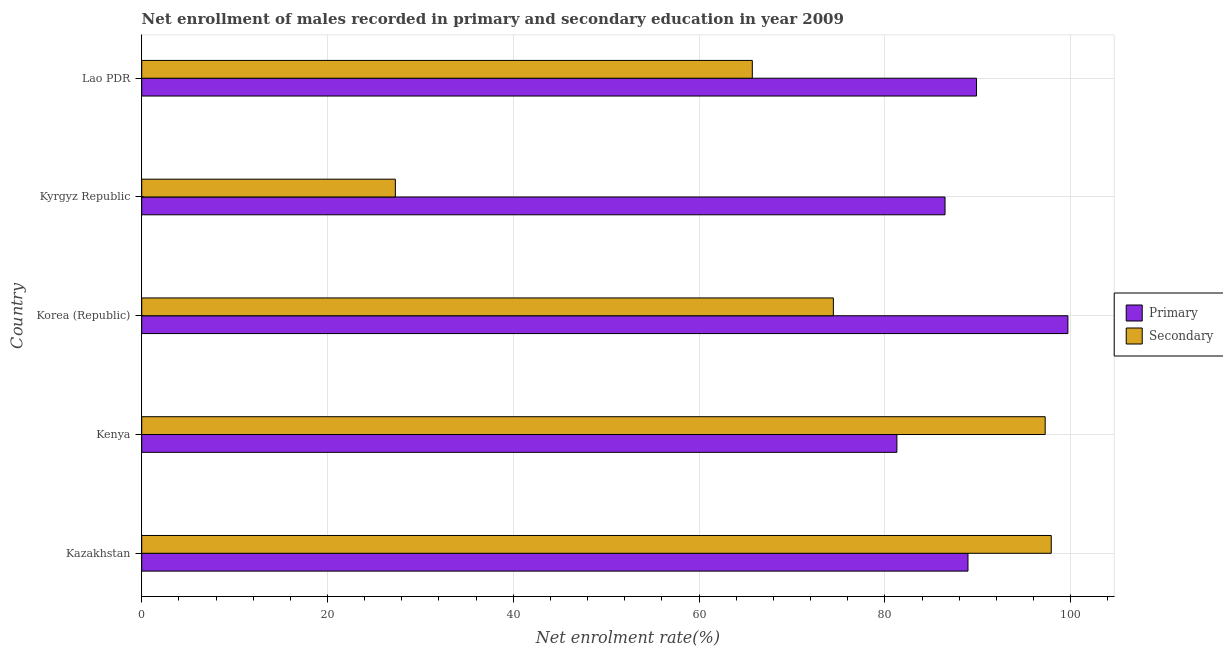How many different coloured bars are there?
Your answer should be compact. 2. How many groups of bars are there?
Provide a succinct answer. 5. How many bars are there on the 2nd tick from the bottom?
Ensure brevity in your answer.  2. What is the label of the 5th group of bars from the top?
Provide a succinct answer. Kazakhstan. In how many cases, is the number of bars for a given country not equal to the number of legend labels?
Keep it short and to the point. 0. What is the enrollment rate in secondary education in Korea (Republic)?
Provide a short and direct response. 74.46. Across all countries, what is the maximum enrollment rate in primary education?
Give a very brief answer. 99.71. Across all countries, what is the minimum enrollment rate in secondary education?
Make the answer very short. 27.3. In which country was the enrollment rate in secondary education maximum?
Offer a very short reply. Kazakhstan. In which country was the enrollment rate in primary education minimum?
Ensure brevity in your answer.  Kenya. What is the total enrollment rate in secondary education in the graph?
Provide a succinct answer. 362.67. What is the difference between the enrollment rate in primary education in Korea (Republic) and that in Lao PDR?
Offer a terse response. 9.84. What is the difference between the enrollment rate in secondary education in Kenya and the enrollment rate in primary education in Lao PDR?
Your answer should be very brief. 7.39. What is the average enrollment rate in primary education per country?
Ensure brevity in your answer.  89.26. What is the difference between the enrollment rate in secondary education and enrollment rate in primary education in Korea (Republic)?
Keep it short and to the point. -25.25. What is the ratio of the enrollment rate in secondary education in Korea (Republic) to that in Kyrgyz Republic?
Keep it short and to the point. 2.73. What is the difference between the highest and the second highest enrollment rate in primary education?
Keep it short and to the point. 9.84. What is the difference between the highest and the lowest enrollment rate in primary education?
Offer a terse response. 18.41. In how many countries, is the enrollment rate in primary education greater than the average enrollment rate in primary education taken over all countries?
Ensure brevity in your answer.  2. What does the 2nd bar from the top in Korea (Republic) represents?
Give a very brief answer. Primary. What does the 1st bar from the bottom in Korea (Republic) represents?
Provide a short and direct response. Primary. How many bars are there?
Give a very brief answer. 10. Are all the bars in the graph horizontal?
Ensure brevity in your answer.  Yes. What is the difference between two consecutive major ticks on the X-axis?
Offer a very short reply. 20. Where does the legend appear in the graph?
Provide a succinct answer. Center right. How many legend labels are there?
Provide a short and direct response. 2. How are the legend labels stacked?
Provide a succinct answer. Vertical. What is the title of the graph?
Provide a succinct answer. Net enrollment of males recorded in primary and secondary education in year 2009. Does "2012 US$" appear as one of the legend labels in the graph?
Give a very brief answer. No. What is the label or title of the X-axis?
Make the answer very short. Net enrolment rate(%). What is the Net enrolment rate(%) in Primary in Kazakhstan?
Keep it short and to the point. 88.95. What is the Net enrolment rate(%) of Secondary in Kazakhstan?
Offer a very short reply. 97.92. What is the Net enrolment rate(%) of Primary in Kenya?
Make the answer very short. 81.3. What is the Net enrolment rate(%) of Secondary in Kenya?
Offer a terse response. 97.26. What is the Net enrolment rate(%) in Primary in Korea (Republic)?
Your answer should be very brief. 99.71. What is the Net enrolment rate(%) in Secondary in Korea (Republic)?
Ensure brevity in your answer.  74.46. What is the Net enrolment rate(%) in Primary in Kyrgyz Republic?
Offer a very short reply. 86.48. What is the Net enrolment rate(%) in Secondary in Kyrgyz Republic?
Offer a terse response. 27.3. What is the Net enrolment rate(%) in Primary in Lao PDR?
Your response must be concise. 89.87. What is the Net enrolment rate(%) in Secondary in Lao PDR?
Your answer should be compact. 65.73. Across all countries, what is the maximum Net enrolment rate(%) of Primary?
Give a very brief answer. 99.71. Across all countries, what is the maximum Net enrolment rate(%) in Secondary?
Provide a short and direct response. 97.92. Across all countries, what is the minimum Net enrolment rate(%) in Primary?
Your answer should be very brief. 81.3. Across all countries, what is the minimum Net enrolment rate(%) in Secondary?
Give a very brief answer. 27.3. What is the total Net enrolment rate(%) in Primary in the graph?
Provide a short and direct response. 446.31. What is the total Net enrolment rate(%) in Secondary in the graph?
Give a very brief answer. 362.67. What is the difference between the Net enrolment rate(%) in Primary in Kazakhstan and that in Kenya?
Give a very brief answer. 7.65. What is the difference between the Net enrolment rate(%) of Secondary in Kazakhstan and that in Kenya?
Keep it short and to the point. 0.65. What is the difference between the Net enrolment rate(%) of Primary in Kazakhstan and that in Korea (Republic)?
Offer a terse response. -10.76. What is the difference between the Net enrolment rate(%) of Secondary in Kazakhstan and that in Korea (Republic)?
Provide a succinct answer. 23.46. What is the difference between the Net enrolment rate(%) of Primary in Kazakhstan and that in Kyrgyz Republic?
Give a very brief answer. 2.47. What is the difference between the Net enrolment rate(%) in Secondary in Kazakhstan and that in Kyrgyz Republic?
Provide a short and direct response. 70.61. What is the difference between the Net enrolment rate(%) of Primary in Kazakhstan and that in Lao PDR?
Ensure brevity in your answer.  -0.92. What is the difference between the Net enrolment rate(%) of Secondary in Kazakhstan and that in Lao PDR?
Provide a succinct answer. 32.18. What is the difference between the Net enrolment rate(%) of Primary in Kenya and that in Korea (Republic)?
Make the answer very short. -18.41. What is the difference between the Net enrolment rate(%) in Secondary in Kenya and that in Korea (Republic)?
Provide a short and direct response. 22.8. What is the difference between the Net enrolment rate(%) of Primary in Kenya and that in Kyrgyz Republic?
Provide a succinct answer. -5.18. What is the difference between the Net enrolment rate(%) in Secondary in Kenya and that in Kyrgyz Republic?
Ensure brevity in your answer.  69.96. What is the difference between the Net enrolment rate(%) of Primary in Kenya and that in Lao PDR?
Provide a succinct answer. -8.57. What is the difference between the Net enrolment rate(%) of Secondary in Kenya and that in Lao PDR?
Offer a terse response. 31.53. What is the difference between the Net enrolment rate(%) in Primary in Korea (Republic) and that in Kyrgyz Republic?
Ensure brevity in your answer.  13.23. What is the difference between the Net enrolment rate(%) of Secondary in Korea (Republic) and that in Kyrgyz Republic?
Your answer should be compact. 47.15. What is the difference between the Net enrolment rate(%) of Primary in Korea (Republic) and that in Lao PDR?
Ensure brevity in your answer.  9.84. What is the difference between the Net enrolment rate(%) in Secondary in Korea (Republic) and that in Lao PDR?
Your answer should be compact. 8.73. What is the difference between the Net enrolment rate(%) of Primary in Kyrgyz Republic and that in Lao PDR?
Offer a terse response. -3.39. What is the difference between the Net enrolment rate(%) of Secondary in Kyrgyz Republic and that in Lao PDR?
Provide a succinct answer. -38.43. What is the difference between the Net enrolment rate(%) of Primary in Kazakhstan and the Net enrolment rate(%) of Secondary in Kenya?
Ensure brevity in your answer.  -8.31. What is the difference between the Net enrolment rate(%) in Primary in Kazakhstan and the Net enrolment rate(%) in Secondary in Korea (Republic)?
Your answer should be very brief. 14.49. What is the difference between the Net enrolment rate(%) in Primary in Kazakhstan and the Net enrolment rate(%) in Secondary in Kyrgyz Republic?
Keep it short and to the point. 61.65. What is the difference between the Net enrolment rate(%) of Primary in Kazakhstan and the Net enrolment rate(%) of Secondary in Lao PDR?
Give a very brief answer. 23.22. What is the difference between the Net enrolment rate(%) in Primary in Kenya and the Net enrolment rate(%) in Secondary in Korea (Republic)?
Ensure brevity in your answer.  6.84. What is the difference between the Net enrolment rate(%) of Primary in Kenya and the Net enrolment rate(%) of Secondary in Kyrgyz Republic?
Your response must be concise. 53.99. What is the difference between the Net enrolment rate(%) in Primary in Kenya and the Net enrolment rate(%) in Secondary in Lao PDR?
Your response must be concise. 15.56. What is the difference between the Net enrolment rate(%) of Primary in Korea (Republic) and the Net enrolment rate(%) of Secondary in Kyrgyz Republic?
Your response must be concise. 72.4. What is the difference between the Net enrolment rate(%) of Primary in Korea (Republic) and the Net enrolment rate(%) of Secondary in Lao PDR?
Offer a very short reply. 33.98. What is the difference between the Net enrolment rate(%) in Primary in Kyrgyz Republic and the Net enrolment rate(%) in Secondary in Lao PDR?
Keep it short and to the point. 20.75. What is the average Net enrolment rate(%) of Primary per country?
Offer a very short reply. 89.26. What is the average Net enrolment rate(%) in Secondary per country?
Your answer should be very brief. 72.53. What is the difference between the Net enrolment rate(%) of Primary and Net enrolment rate(%) of Secondary in Kazakhstan?
Ensure brevity in your answer.  -8.96. What is the difference between the Net enrolment rate(%) of Primary and Net enrolment rate(%) of Secondary in Kenya?
Your answer should be very brief. -15.96. What is the difference between the Net enrolment rate(%) in Primary and Net enrolment rate(%) in Secondary in Korea (Republic)?
Your answer should be very brief. 25.25. What is the difference between the Net enrolment rate(%) of Primary and Net enrolment rate(%) of Secondary in Kyrgyz Republic?
Give a very brief answer. 59.18. What is the difference between the Net enrolment rate(%) of Primary and Net enrolment rate(%) of Secondary in Lao PDR?
Offer a very short reply. 24.14. What is the ratio of the Net enrolment rate(%) of Primary in Kazakhstan to that in Kenya?
Your response must be concise. 1.09. What is the ratio of the Net enrolment rate(%) in Primary in Kazakhstan to that in Korea (Republic)?
Make the answer very short. 0.89. What is the ratio of the Net enrolment rate(%) of Secondary in Kazakhstan to that in Korea (Republic)?
Make the answer very short. 1.31. What is the ratio of the Net enrolment rate(%) of Primary in Kazakhstan to that in Kyrgyz Republic?
Give a very brief answer. 1.03. What is the ratio of the Net enrolment rate(%) of Secondary in Kazakhstan to that in Kyrgyz Republic?
Keep it short and to the point. 3.59. What is the ratio of the Net enrolment rate(%) of Secondary in Kazakhstan to that in Lao PDR?
Provide a short and direct response. 1.49. What is the ratio of the Net enrolment rate(%) of Primary in Kenya to that in Korea (Republic)?
Your response must be concise. 0.82. What is the ratio of the Net enrolment rate(%) in Secondary in Kenya to that in Korea (Republic)?
Ensure brevity in your answer.  1.31. What is the ratio of the Net enrolment rate(%) of Primary in Kenya to that in Kyrgyz Republic?
Keep it short and to the point. 0.94. What is the ratio of the Net enrolment rate(%) in Secondary in Kenya to that in Kyrgyz Republic?
Ensure brevity in your answer.  3.56. What is the ratio of the Net enrolment rate(%) in Primary in Kenya to that in Lao PDR?
Give a very brief answer. 0.9. What is the ratio of the Net enrolment rate(%) in Secondary in Kenya to that in Lao PDR?
Ensure brevity in your answer.  1.48. What is the ratio of the Net enrolment rate(%) in Primary in Korea (Republic) to that in Kyrgyz Republic?
Keep it short and to the point. 1.15. What is the ratio of the Net enrolment rate(%) of Secondary in Korea (Republic) to that in Kyrgyz Republic?
Keep it short and to the point. 2.73. What is the ratio of the Net enrolment rate(%) in Primary in Korea (Republic) to that in Lao PDR?
Keep it short and to the point. 1.11. What is the ratio of the Net enrolment rate(%) of Secondary in Korea (Republic) to that in Lao PDR?
Your answer should be very brief. 1.13. What is the ratio of the Net enrolment rate(%) of Primary in Kyrgyz Republic to that in Lao PDR?
Keep it short and to the point. 0.96. What is the ratio of the Net enrolment rate(%) in Secondary in Kyrgyz Republic to that in Lao PDR?
Offer a terse response. 0.42. What is the difference between the highest and the second highest Net enrolment rate(%) in Primary?
Provide a short and direct response. 9.84. What is the difference between the highest and the second highest Net enrolment rate(%) of Secondary?
Offer a very short reply. 0.65. What is the difference between the highest and the lowest Net enrolment rate(%) in Primary?
Keep it short and to the point. 18.41. What is the difference between the highest and the lowest Net enrolment rate(%) of Secondary?
Your response must be concise. 70.61. 